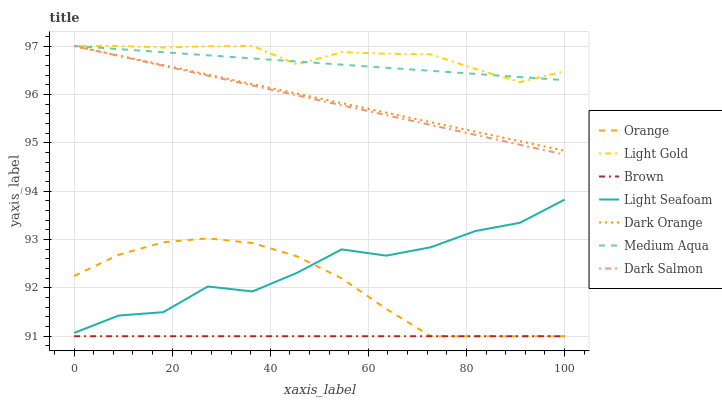Does Dark Orange have the minimum area under the curve?
Answer yes or no. No. Does Dark Orange have the maximum area under the curve?
Answer yes or no. No. Is Dark Orange the smoothest?
Answer yes or no. No. Is Dark Orange the roughest?
Answer yes or no. No. Does Dark Orange have the lowest value?
Answer yes or no. No. Does Orange have the highest value?
Answer yes or no. No. Is Brown less than Light Gold?
Answer yes or no. Yes. Is Dark Orange greater than Orange?
Answer yes or no. Yes. Does Brown intersect Light Gold?
Answer yes or no. No. 